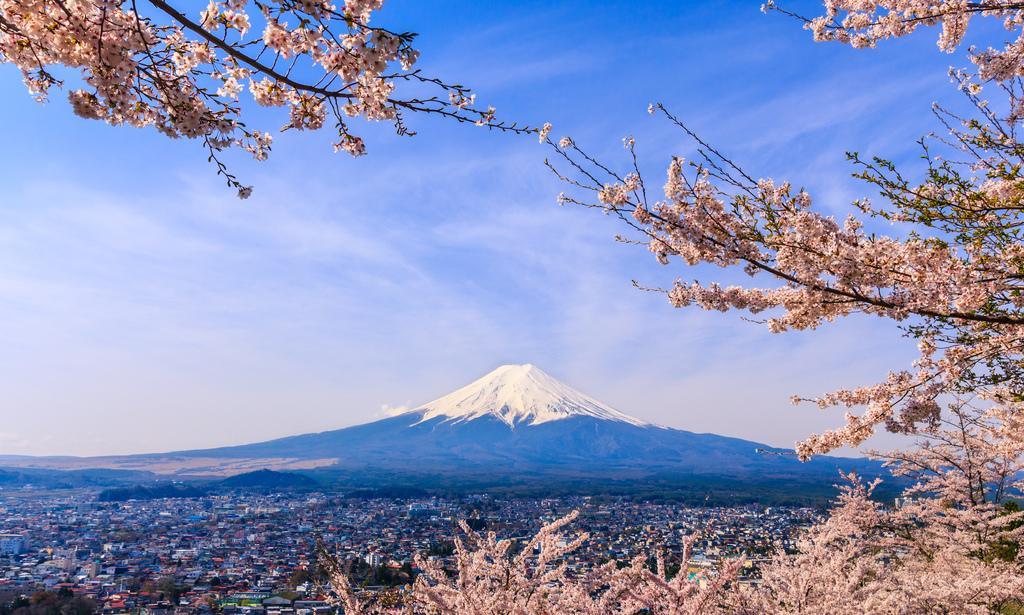How would you summarize this image in a sentence or two? In the foreground of the image we can see the tree. In the background, we can see houses, a mountain and the sky with clouds. 